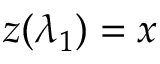<formula> <loc_0><loc_0><loc_500><loc_500>z ( \lambda _ { 1 } ) = x</formula> 